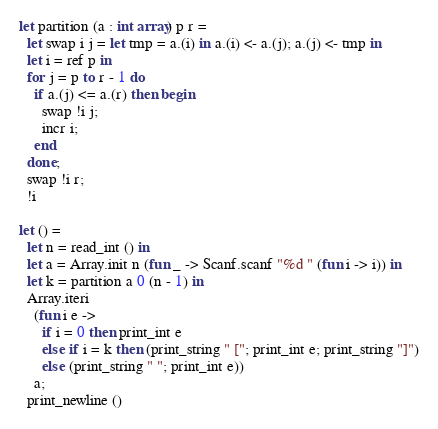<code> <loc_0><loc_0><loc_500><loc_500><_OCaml_>let partition (a : int array) p r =
  let swap i j = let tmp = a.(i) in a.(i) <- a.(j); a.(j) <- tmp in
  let i = ref p in
  for j = p to r - 1 do
    if a.(j) <= a.(r) then begin
      swap !i j;
      incr i;
    end
  done;
  swap !i r;
  !i

let () =
  let n = read_int () in
  let a = Array.init n (fun _ -> Scanf.scanf "%d " (fun i -> i)) in
  let k = partition a 0 (n - 1) in
  Array.iteri
    (fun i e ->
      if i = 0 then print_int e
      else if i = k then (print_string " ["; print_int e; print_string "]")
      else (print_string " "; print_int e))
    a;
  print_newline ()</code> 